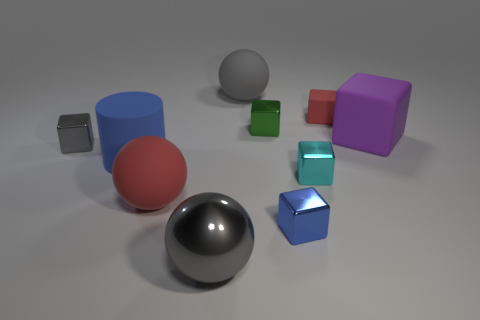There is a red thing that is on the right side of the large shiny object; is its size the same as the blue thing in front of the cyan block?
Provide a short and direct response. Yes. What number of blocks are either small matte things or big gray metallic objects?
Offer a terse response. 1. What number of matte objects are either tiny red things or purple blocks?
Keep it short and to the point. 2. The red thing that is the same shape as the small gray object is what size?
Give a very brief answer. Small. There is a gray rubber ball; does it have the same size as the cylinder left of the red matte sphere?
Your response must be concise. Yes. There is a gray object behind the small gray object; what shape is it?
Make the answer very short. Sphere. The metal cube that is to the left of the red matte thing that is in front of the red rubber cube is what color?
Offer a very short reply. Gray. What color is the large matte thing that is the same shape as the cyan shiny thing?
Give a very brief answer. Purple. How many metallic cubes have the same color as the big cylinder?
Offer a terse response. 1. There is a big cylinder; does it have the same color as the small object that is in front of the tiny cyan metallic thing?
Keep it short and to the point. Yes. 